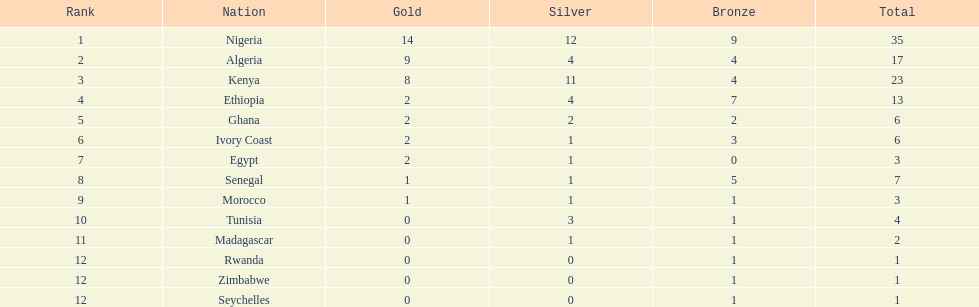The team with the most gold medals Nigeria. Can you give me this table as a dict? {'header': ['Rank', 'Nation', 'Gold', 'Silver', 'Bronze', 'Total'], 'rows': [['1', 'Nigeria', '14', '12', '9', '35'], ['2', 'Algeria', '9', '4', '4', '17'], ['3', 'Kenya', '8', '11', '4', '23'], ['4', 'Ethiopia', '2', '4', '7', '13'], ['5', 'Ghana', '2', '2', '2', '6'], ['6', 'Ivory Coast', '2', '1', '3', '6'], ['7', 'Egypt', '2', '1', '0', '3'], ['8', 'Senegal', '1', '1', '5', '7'], ['9', 'Morocco', '1', '1', '1', '3'], ['10', 'Tunisia', '0', '3', '1', '4'], ['11', 'Madagascar', '0', '1', '1', '2'], ['12', 'Rwanda', '0', '0', '1', '1'], ['12', 'Zimbabwe', '0', '0', '1', '1'], ['12', 'Seychelles', '0', '0', '1', '1']]} 